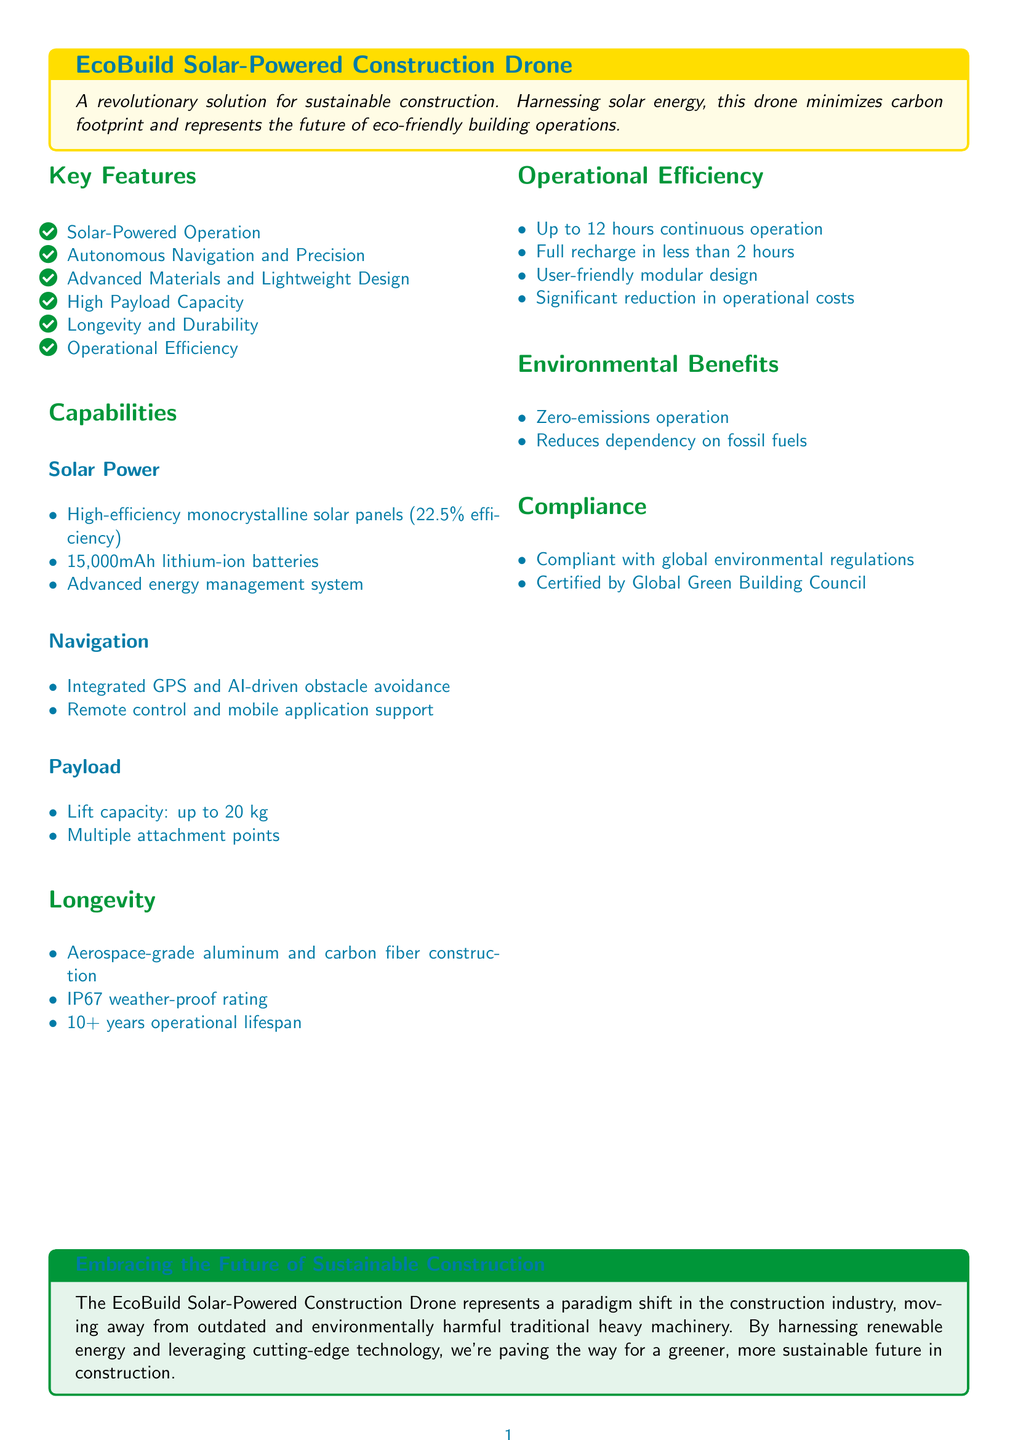What is the efficiency percentage of the solar panels? The document states that the high-efficiency monocrystalline solar panels have an efficiency of 22.5%.
Answer: 22.5% What is the lift capacity of the drone? The drone has a lift capacity of up to 20 kg, as mentioned in the payload section.
Answer: 20 kg What is the operational lifespan of the drone? The document indicates that the drone has an operational lifespan of over 10 years.
Answer: 10+ years How long can the drone operate continuously? The operational efficiency section mentions that the drone can operate continuously for up to 12 hours.
Answer: 12 hours What materials are used in the construction of the drone? The documentation specifies aerospace-grade aluminum and carbon fiber as the materials used for the drone's construction.
Answer: Aerospace-grade aluminum and carbon fiber What is the recharge time for the drone? According to the operational efficiency section, the drone fully recharges in less than 2 hours.
Answer: Less than 2 hours How does this drone benefit the environment? The environmental benefits section states it operates with zero emissions and reduces dependency on fossil fuels.
Answer: Zero-emissions operation Is the drone compliant with environmental regulations? The document confirms that the drone is compliant with global environmental regulations and certified by the Global Green Building Council.
Answer: Compliant with global environmental regulations 